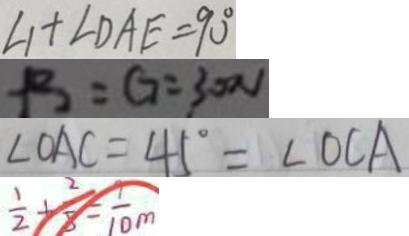Convert formula to latex. <formula><loc_0><loc_0><loc_500><loc_500>\angle 1 + \angle D A E = 9 0 ^ { \circ } 
 P _ { 2 } = G = 3 0 0 v 
 \angle O A C = 4 5 ^ { \circ } = \angle O C A 
 \frac { 1 } { 2 } + \frac { 2 } { 5 } = \frac { 9 } { 1 0 } m</formula> 